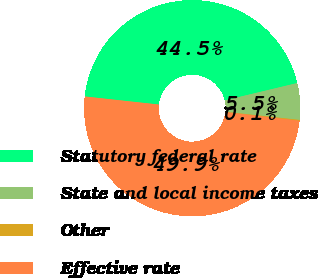<chart> <loc_0><loc_0><loc_500><loc_500><pie_chart><fcel>Statutory federal rate<fcel>State and local income taxes<fcel>Other<fcel>Effective rate<nl><fcel>44.53%<fcel>5.47%<fcel>0.13%<fcel>49.87%<nl></chart> 